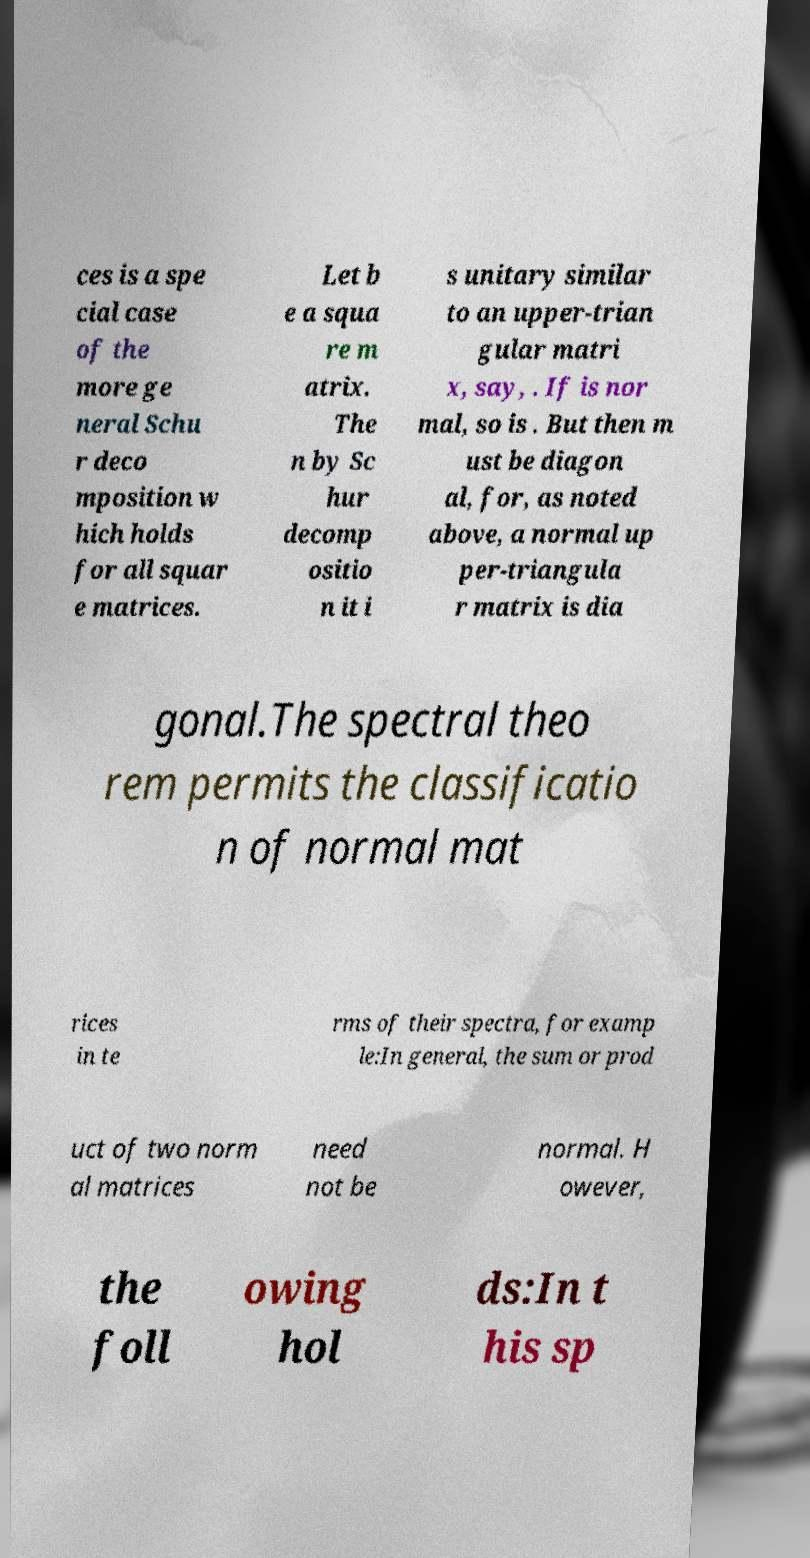Could you extract and type out the text from this image? ces is a spe cial case of the more ge neral Schu r deco mposition w hich holds for all squar e matrices. Let b e a squa re m atrix. The n by Sc hur decomp ositio n it i s unitary similar to an upper-trian gular matri x, say, . If is nor mal, so is . But then m ust be diagon al, for, as noted above, a normal up per-triangula r matrix is dia gonal.The spectral theo rem permits the classificatio n of normal mat rices in te rms of their spectra, for examp le:In general, the sum or prod uct of two norm al matrices need not be normal. H owever, the foll owing hol ds:In t his sp 